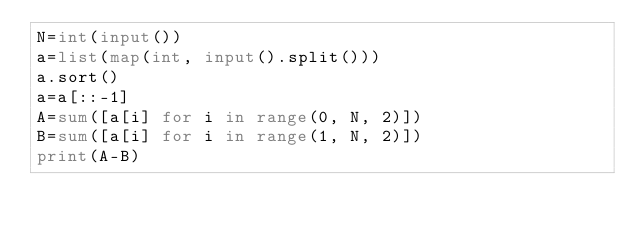<code> <loc_0><loc_0><loc_500><loc_500><_Python_>N=int(input())
a=list(map(int, input().split()))
a.sort()
a=a[::-1]
A=sum([a[i] for i in range(0, N, 2)])
B=sum([a[i] for i in range(1, N, 2)])
print(A-B)</code> 